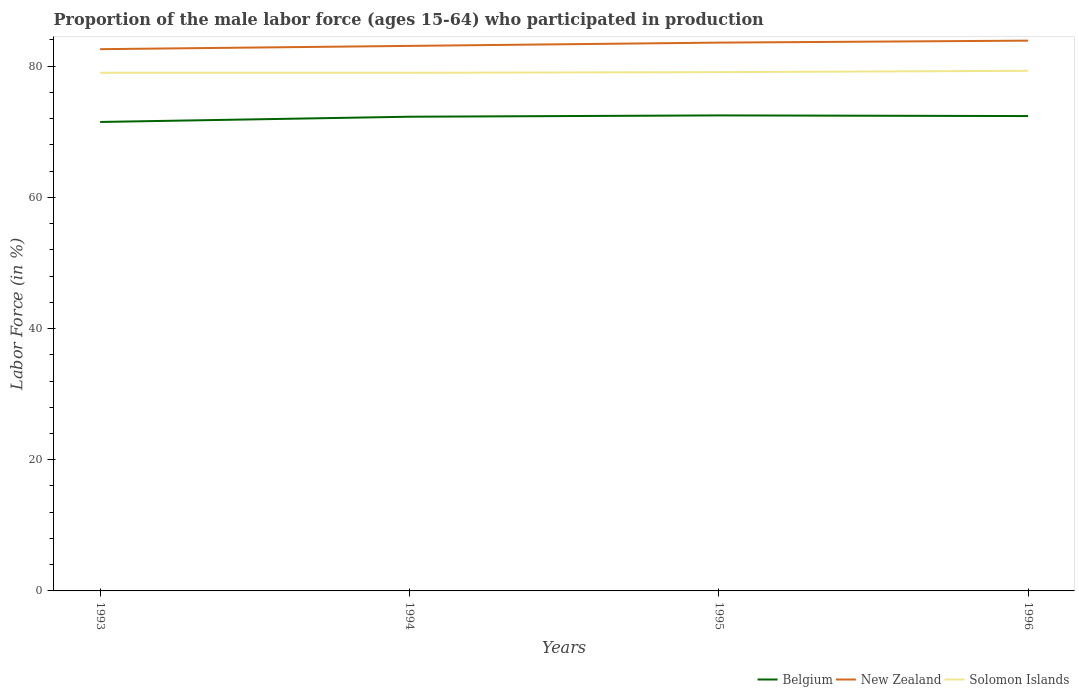How many different coloured lines are there?
Your answer should be very brief. 3. Does the line corresponding to Belgium intersect with the line corresponding to New Zealand?
Your response must be concise. No. Is the number of lines equal to the number of legend labels?
Your answer should be very brief. Yes. Across all years, what is the maximum proportion of the male labor force who participated in production in New Zealand?
Your answer should be very brief. 82.6. In which year was the proportion of the male labor force who participated in production in Solomon Islands maximum?
Give a very brief answer. 1993. What is the total proportion of the male labor force who participated in production in Belgium in the graph?
Keep it short and to the point. -0.1. What is the difference between the highest and the second highest proportion of the male labor force who participated in production in Solomon Islands?
Your answer should be compact. 0.3. Is the proportion of the male labor force who participated in production in Solomon Islands strictly greater than the proportion of the male labor force who participated in production in Belgium over the years?
Provide a short and direct response. No. How many lines are there?
Make the answer very short. 3. What is the difference between two consecutive major ticks on the Y-axis?
Provide a short and direct response. 20. Does the graph contain grids?
Make the answer very short. No. How are the legend labels stacked?
Give a very brief answer. Horizontal. What is the title of the graph?
Provide a succinct answer. Proportion of the male labor force (ages 15-64) who participated in production. What is the label or title of the X-axis?
Keep it short and to the point. Years. What is the Labor Force (in %) in Belgium in 1993?
Give a very brief answer. 71.5. What is the Labor Force (in %) of New Zealand in 1993?
Provide a short and direct response. 82.6. What is the Labor Force (in %) in Solomon Islands in 1993?
Keep it short and to the point. 79. What is the Labor Force (in %) in Belgium in 1994?
Your response must be concise. 72.3. What is the Labor Force (in %) in New Zealand in 1994?
Make the answer very short. 83.1. What is the Labor Force (in %) in Solomon Islands in 1994?
Make the answer very short. 79. What is the Labor Force (in %) in Belgium in 1995?
Make the answer very short. 72.5. What is the Labor Force (in %) in New Zealand in 1995?
Offer a terse response. 83.6. What is the Labor Force (in %) of Solomon Islands in 1995?
Ensure brevity in your answer.  79.1. What is the Labor Force (in %) of Belgium in 1996?
Your answer should be very brief. 72.4. What is the Labor Force (in %) of New Zealand in 1996?
Your answer should be compact. 83.9. What is the Labor Force (in %) in Solomon Islands in 1996?
Your answer should be compact. 79.3. Across all years, what is the maximum Labor Force (in %) in Belgium?
Your answer should be compact. 72.5. Across all years, what is the maximum Labor Force (in %) of New Zealand?
Make the answer very short. 83.9. Across all years, what is the maximum Labor Force (in %) in Solomon Islands?
Your answer should be compact. 79.3. Across all years, what is the minimum Labor Force (in %) of Belgium?
Your answer should be compact. 71.5. Across all years, what is the minimum Labor Force (in %) of New Zealand?
Make the answer very short. 82.6. Across all years, what is the minimum Labor Force (in %) of Solomon Islands?
Your answer should be compact. 79. What is the total Labor Force (in %) in Belgium in the graph?
Ensure brevity in your answer.  288.7. What is the total Labor Force (in %) of New Zealand in the graph?
Provide a succinct answer. 333.2. What is the total Labor Force (in %) in Solomon Islands in the graph?
Provide a short and direct response. 316.4. What is the difference between the Labor Force (in %) in Belgium in 1993 and that in 1994?
Provide a succinct answer. -0.8. What is the difference between the Labor Force (in %) of New Zealand in 1993 and that in 1994?
Ensure brevity in your answer.  -0.5. What is the difference between the Labor Force (in %) of Belgium in 1993 and that in 1995?
Your response must be concise. -1. What is the difference between the Labor Force (in %) of Belgium in 1993 and that in 1996?
Offer a very short reply. -0.9. What is the difference between the Labor Force (in %) in New Zealand in 1993 and that in 1996?
Give a very brief answer. -1.3. What is the difference between the Labor Force (in %) in Belgium in 1994 and that in 1995?
Make the answer very short. -0.2. What is the difference between the Labor Force (in %) of New Zealand in 1994 and that in 1995?
Ensure brevity in your answer.  -0.5. What is the difference between the Labor Force (in %) of Belgium in 1994 and that in 1996?
Make the answer very short. -0.1. What is the difference between the Labor Force (in %) of Solomon Islands in 1994 and that in 1996?
Offer a terse response. -0.3. What is the difference between the Labor Force (in %) of Belgium in 1995 and that in 1996?
Offer a very short reply. 0.1. What is the difference between the Labor Force (in %) in Solomon Islands in 1995 and that in 1996?
Your answer should be very brief. -0.2. What is the difference between the Labor Force (in %) in Belgium in 1993 and the Labor Force (in %) in New Zealand in 1994?
Ensure brevity in your answer.  -11.6. What is the difference between the Labor Force (in %) in Belgium in 1993 and the Labor Force (in %) in Solomon Islands in 1994?
Offer a terse response. -7.5. What is the difference between the Labor Force (in %) in New Zealand in 1993 and the Labor Force (in %) in Solomon Islands in 1994?
Keep it short and to the point. 3.6. What is the difference between the Labor Force (in %) in New Zealand in 1993 and the Labor Force (in %) in Solomon Islands in 1996?
Your answer should be very brief. 3.3. What is the difference between the Labor Force (in %) of Belgium in 1994 and the Labor Force (in %) of New Zealand in 1995?
Your response must be concise. -11.3. What is the difference between the Labor Force (in %) of Belgium in 1994 and the Labor Force (in %) of Solomon Islands in 1996?
Ensure brevity in your answer.  -7. What is the average Labor Force (in %) of Belgium per year?
Your answer should be compact. 72.17. What is the average Labor Force (in %) in New Zealand per year?
Provide a short and direct response. 83.3. What is the average Labor Force (in %) of Solomon Islands per year?
Make the answer very short. 79.1. In the year 1993, what is the difference between the Labor Force (in %) of Belgium and Labor Force (in %) of Solomon Islands?
Your answer should be very brief. -7.5. In the year 1994, what is the difference between the Labor Force (in %) in Belgium and Labor Force (in %) in Solomon Islands?
Your response must be concise. -6.7. In the year 1994, what is the difference between the Labor Force (in %) of New Zealand and Labor Force (in %) of Solomon Islands?
Ensure brevity in your answer.  4.1. In the year 1995, what is the difference between the Labor Force (in %) of Belgium and Labor Force (in %) of New Zealand?
Your response must be concise. -11.1. In the year 1996, what is the difference between the Labor Force (in %) of Belgium and Labor Force (in %) of Solomon Islands?
Your response must be concise. -6.9. In the year 1996, what is the difference between the Labor Force (in %) of New Zealand and Labor Force (in %) of Solomon Islands?
Provide a short and direct response. 4.6. What is the ratio of the Labor Force (in %) in Belgium in 1993 to that in 1994?
Your answer should be very brief. 0.99. What is the ratio of the Labor Force (in %) of Belgium in 1993 to that in 1995?
Provide a short and direct response. 0.99. What is the ratio of the Labor Force (in %) of New Zealand in 1993 to that in 1995?
Offer a very short reply. 0.99. What is the ratio of the Labor Force (in %) in Belgium in 1993 to that in 1996?
Make the answer very short. 0.99. What is the ratio of the Labor Force (in %) of New Zealand in 1993 to that in 1996?
Keep it short and to the point. 0.98. What is the ratio of the Labor Force (in %) in New Zealand in 1994 to that in 1995?
Provide a succinct answer. 0.99. What is the ratio of the Labor Force (in %) in Solomon Islands in 1994 to that in 1996?
Make the answer very short. 1. What is the ratio of the Labor Force (in %) of New Zealand in 1995 to that in 1996?
Your response must be concise. 1. What is the ratio of the Labor Force (in %) in Solomon Islands in 1995 to that in 1996?
Provide a short and direct response. 1. What is the difference between the highest and the second highest Labor Force (in %) of Belgium?
Make the answer very short. 0.1. What is the difference between the highest and the second highest Labor Force (in %) of Solomon Islands?
Make the answer very short. 0.2. What is the difference between the highest and the lowest Labor Force (in %) of New Zealand?
Offer a terse response. 1.3. What is the difference between the highest and the lowest Labor Force (in %) of Solomon Islands?
Your answer should be very brief. 0.3. 